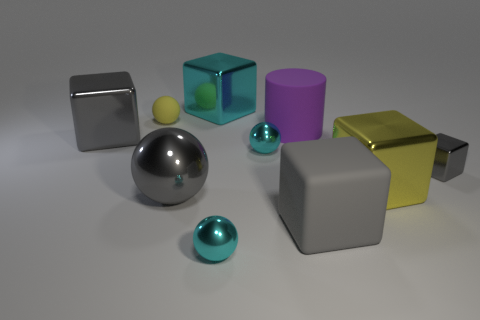Subtract all cyan balls. How many balls are left? 2 Subtract all balls. How many objects are left? 6 Subtract all green shiny cylinders. Subtract all gray rubber objects. How many objects are left? 9 Add 1 gray shiny balls. How many gray shiny balls are left? 2 Add 5 tiny yellow objects. How many tiny yellow objects exist? 6 Subtract all cyan cubes. How many cubes are left? 4 Subtract 0 red blocks. How many objects are left? 10 Subtract 2 cubes. How many cubes are left? 3 Subtract all yellow spheres. Subtract all purple cubes. How many spheres are left? 3 Subtract all purple spheres. How many gray blocks are left? 3 